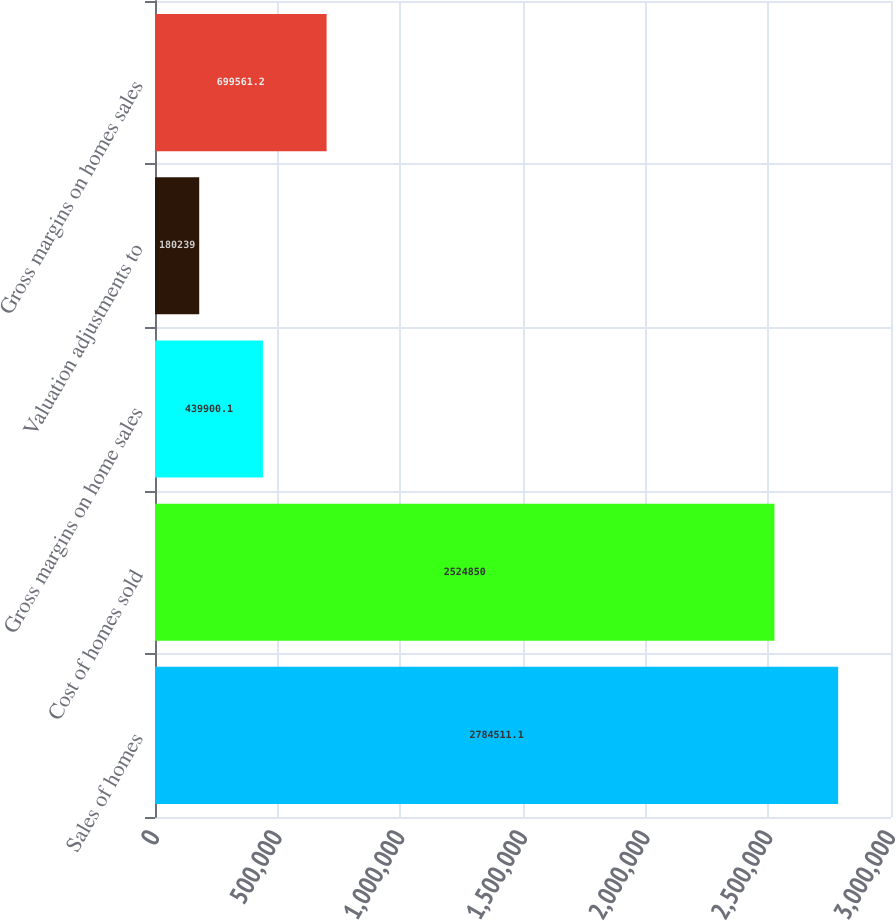Convert chart. <chart><loc_0><loc_0><loc_500><loc_500><bar_chart><fcel>Sales of homes<fcel>Cost of homes sold<fcel>Gross margins on home sales<fcel>Valuation adjustments to<fcel>Gross margins on homes sales<nl><fcel>2.78451e+06<fcel>2.52485e+06<fcel>439900<fcel>180239<fcel>699561<nl></chart> 